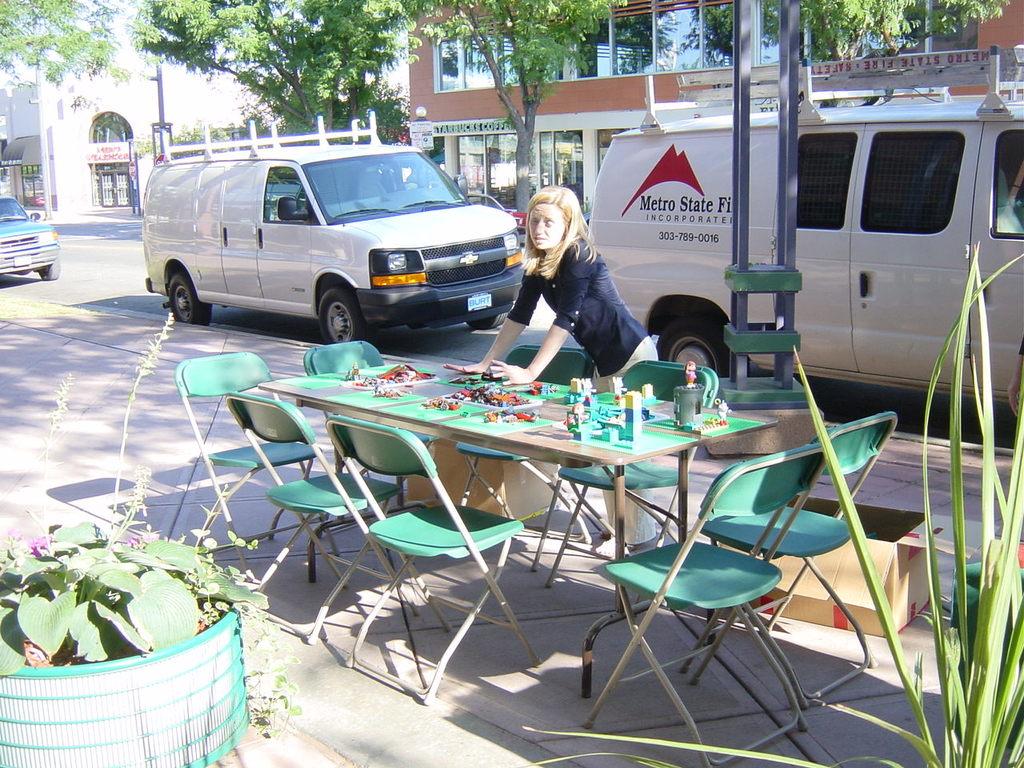What company is on the van?
Offer a terse response. Metro state. What are the first three numbers on the van?
Offer a terse response. 303. 